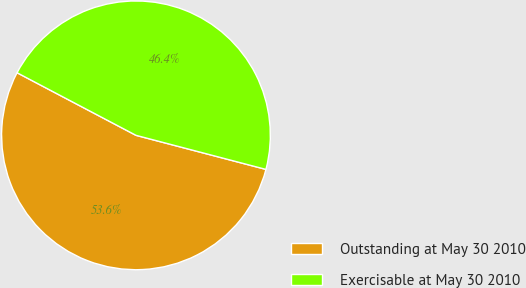Convert chart. <chart><loc_0><loc_0><loc_500><loc_500><pie_chart><fcel>Outstanding at May 30 2010<fcel>Exercisable at May 30 2010<nl><fcel>53.63%<fcel>46.37%<nl></chart> 